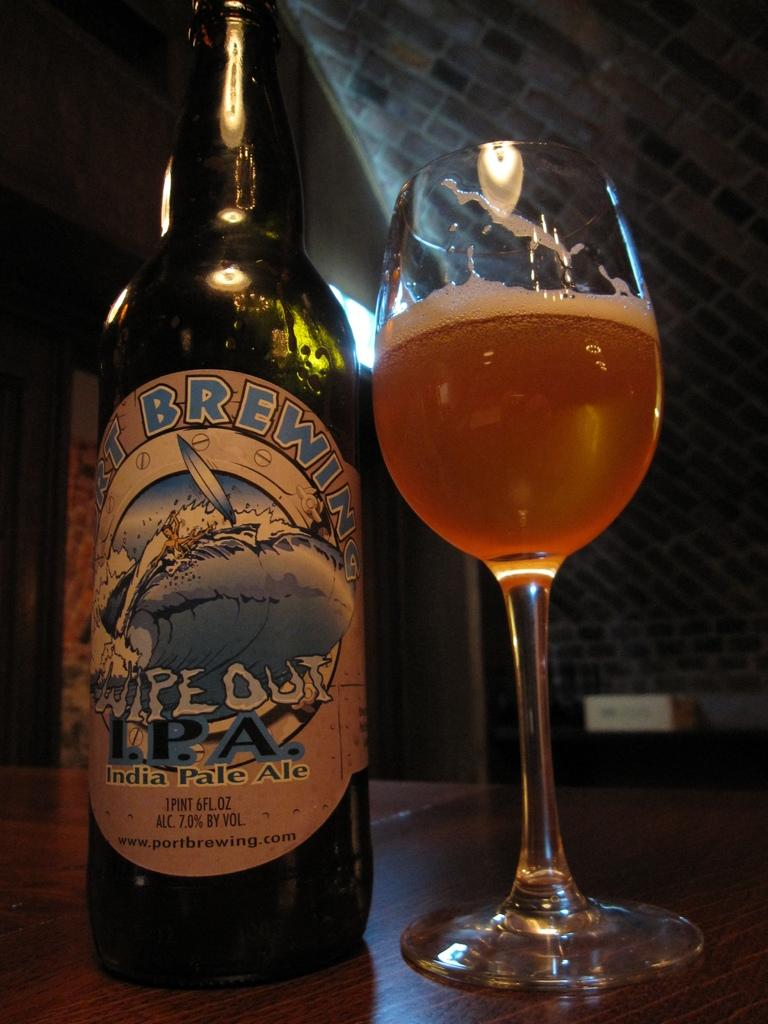<image>
Present a compact description of the photo's key features. Bottle of Wipe Out IPA beer next to a wine glass full of beer. 